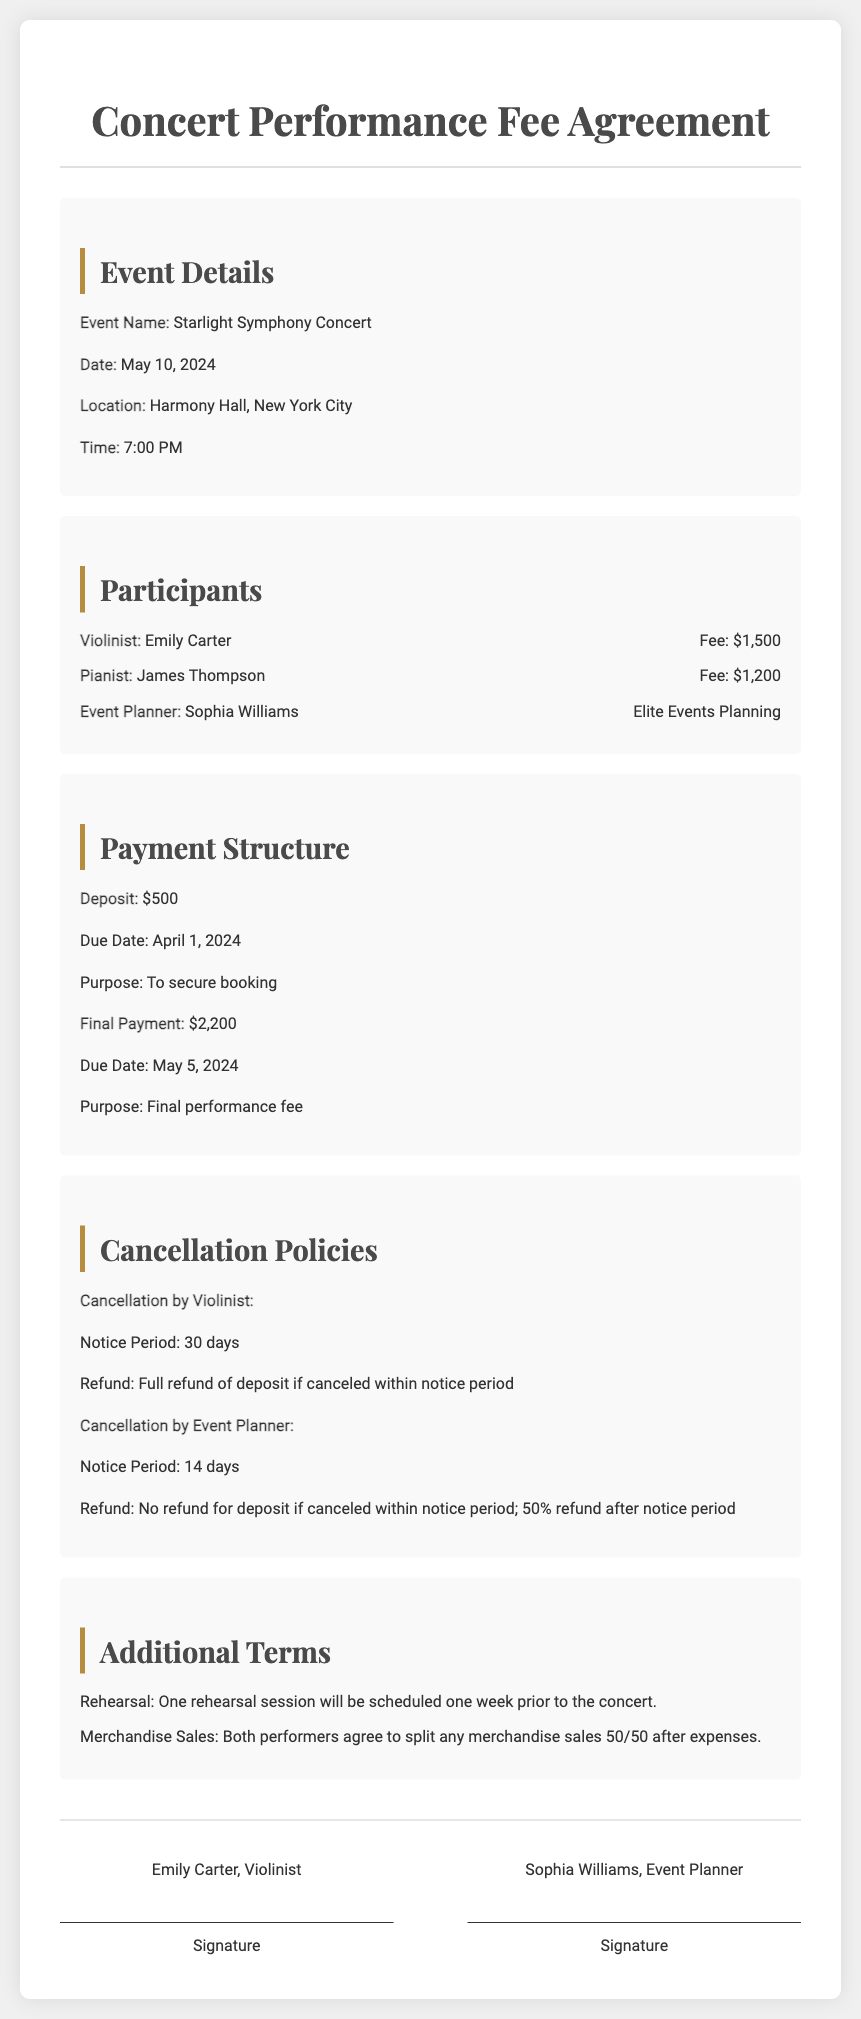What is the event name? The event name is listed in the document under event details, specifying the title of the concert.
Answer: Starlight Symphony Concert What is the date of the concert? The date of the concert is clearly stated in the event details section.
Answer: May 10, 2024 What is the total fee for the violinist? The fee for the violinist is mentioned specifically in the participants section.
Answer: $1,500 What is the notice period for cancellation by the violinist? The notice period for cancellation by the violinist is detailed in the cancellation policies section.
Answer: 30 days What is the final payment due date? The due date for the final payment is provided in the payment structure section of the document.
Answer: May 5, 2024 What is the refund policy if the event planner cancels? The refund policy for cancellation by the event planner is outlined in the cancellation policies section, requiring an understanding of the timeframe for refunds.
Answer: No refund for deposit if canceled within notice period; 50% refund after notice period What is scheduled one week prior to the concert? Additional terms mention an event that will occur prior to the concert, providing context for preparation.
Answer: One rehearsal session How are merchandise sales to be handled? The document outlines the agreement on merchandise sales, requiring knowledge of split responsibilities.
Answer: Split 50/50 after expenses Who is the event planner? The document lists the individuals involved, including their roles and responsibilities in the concert.
Answer: Sophia Williams 